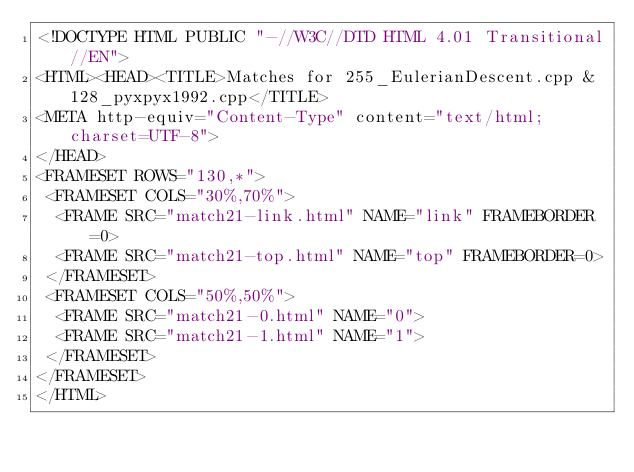<code> <loc_0><loc_0><loc_500><loc_500><_HTML_><!DOCTYPE HTML PUBLIC "-//W3C//DTD HTML 4.01 Transitional//EN">
<HTML><HEAD><TITLE>Matches for 255_EulerianDescent.cpp & 128_pyxpyx1992.cpp</TITLE>
<META http-equiv="Content-Type" content="text/html; charset=UTF-8">
</HEAD>
<FRAMESET ROWS="130,*">
 <FRAMESET COLS="30%,70%">
  <FRAME SRC="match21-link.html" NAME="link" FRAMEBORDER=0>
  <FRAME SRC="match21-top.html" NAME="top" FRAMEBORDER=0>
 </FRAMESET>
 <FRAMESET COLS="50%,50%">
  <FRAME SRC="match21-0.html" NAME="0">
  <FRAME SRC="match21-1.html" NAME="1">
 </FRAMESET>
</FRAMESET>
</HTML>
</code> 